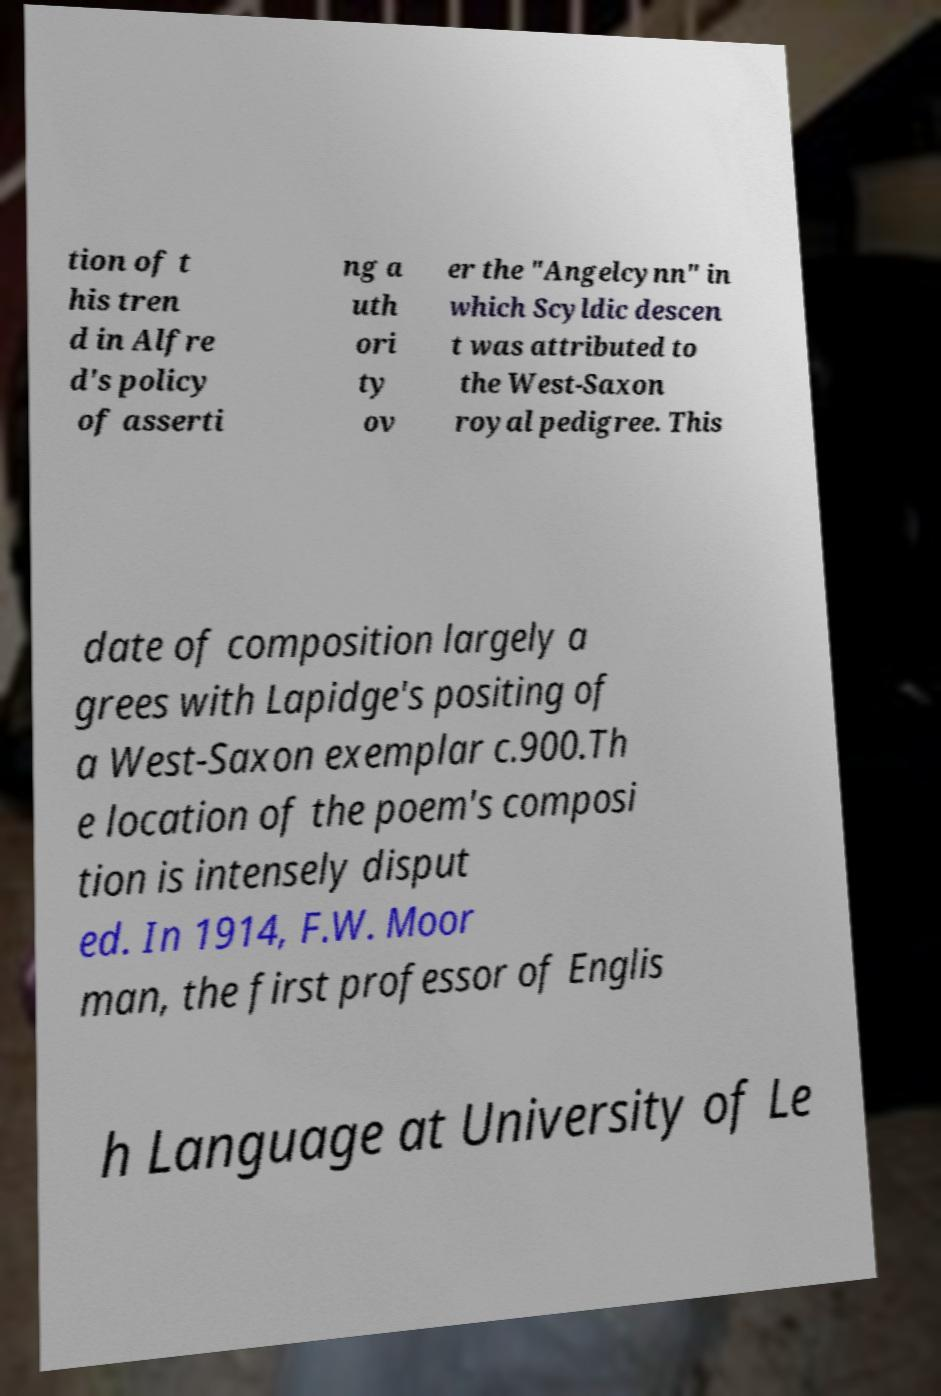For documentation purposes, I need the text within this image transcribed. Could you provide that? tion of t his tren d in Alfre d's policy of asserti ng a uth ori ty ov er the "Angelcynn" in which Scyldic descen t was attributed to the West-Saxon royal pedigree. This date of composition largely a grees with Lapidge's positing of a West-Saxon exemplar c.900.Th e location of the poem's composi tion is intensely disput ed. In 1914, F.W. Moor man, the first professor of Englis h Language at University of Le 